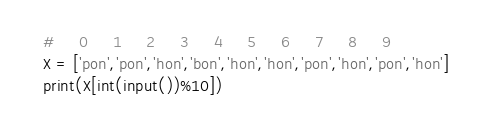Convert code to text. <code><loc_0><loc_0><loc_500><loc_500><_Python_>#     0     1     2     3     4     5     6     7     8     9
X = ['pon','pon','hon','bon','hon','hon','pon','hon','pon','hon']
print(X[int(input())%10])</code> 